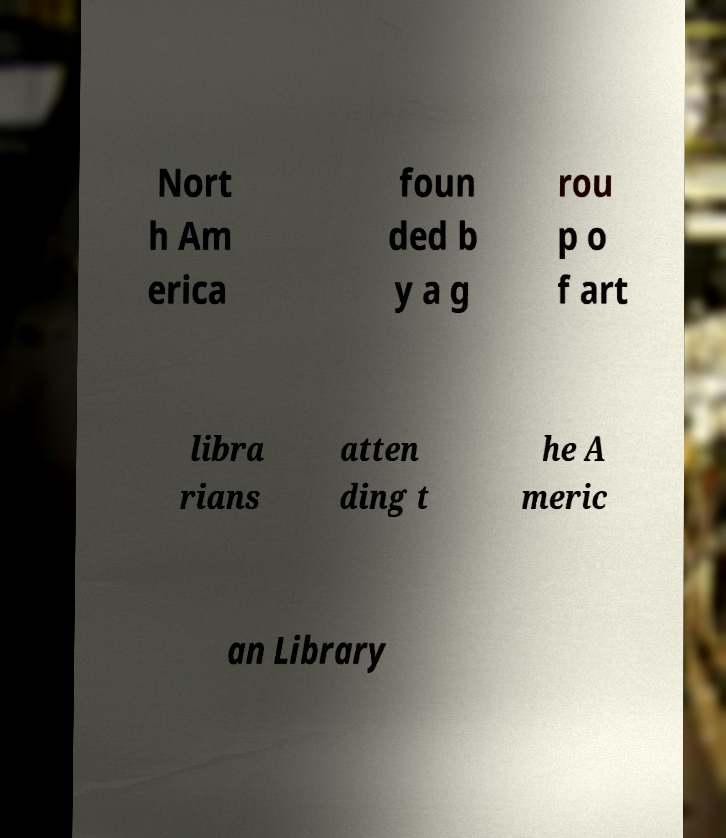Can you read and provide the text displayed in the image?This photo seems to have some interesting text. Can you extract and type it out for me? Nort h Am erica foun ded b y a g rou p o f art libra rians atten ding t he A meric an Library 